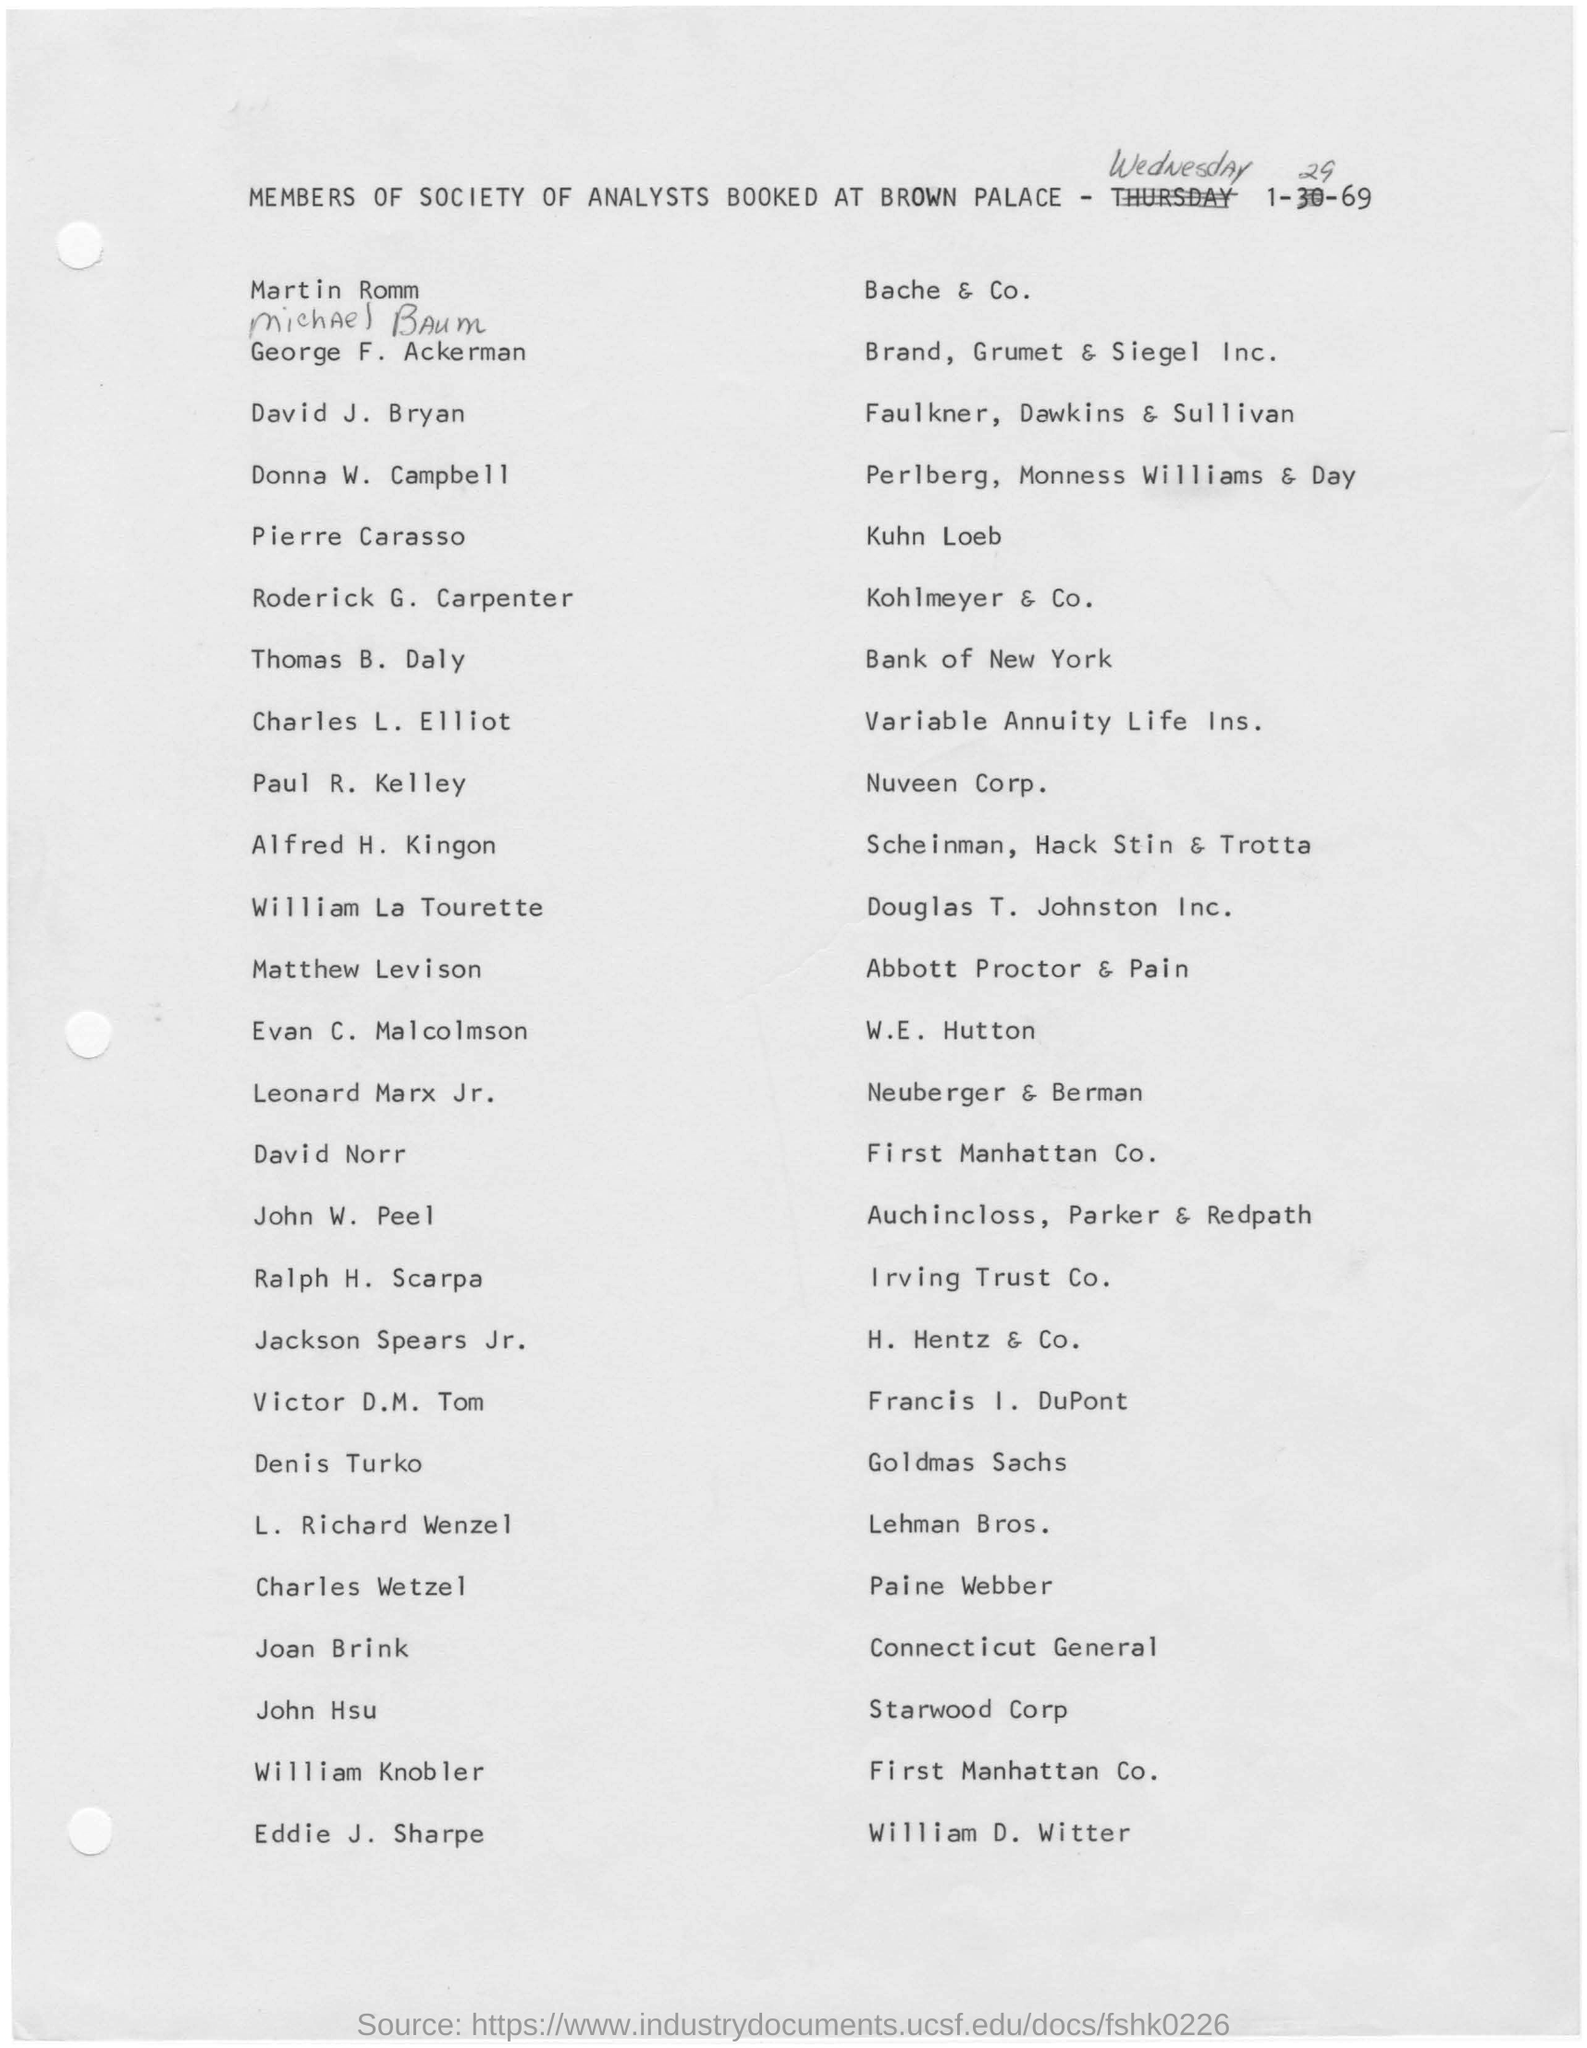What is the week day of the document drafted?
Offer a terse response. WEDNESDAY. Where is David Norr from?
Give a very brief answer. First Manhattan Co. Who is representing from Bank of New York?
Ensure brevity in your answer.  Thomas B. Daly. 